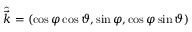<formula> <loc_0><loc_0><loc_500><loc_500>\hat { \vec { k } } = \left ( \cos { \varphi } \cos { \vartheta } , \sin { \varphi } , \cos \varphi \sin { \vartheta } \right )</formula> 